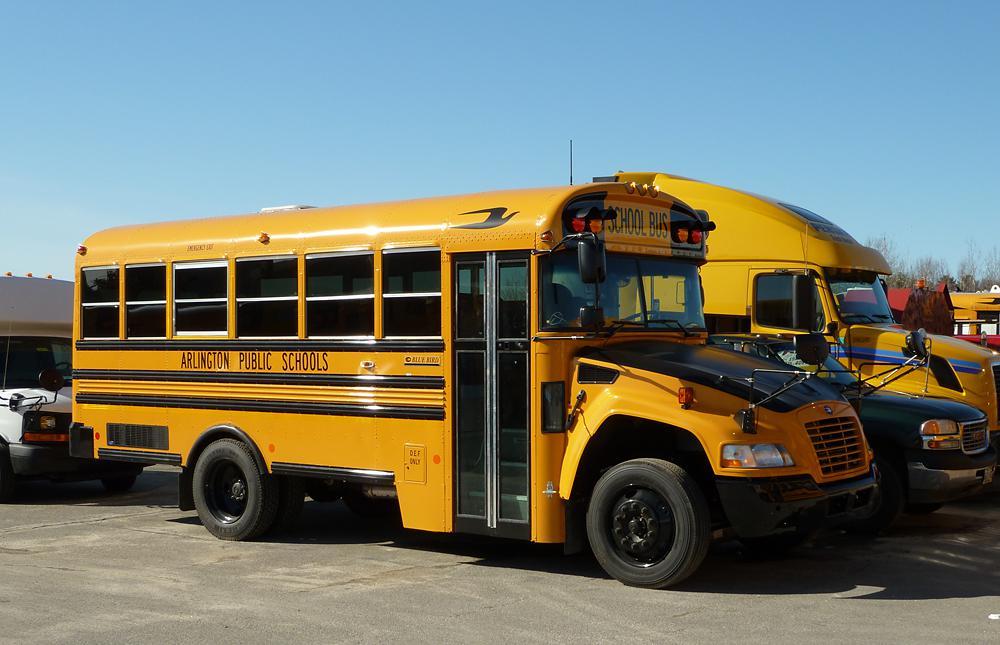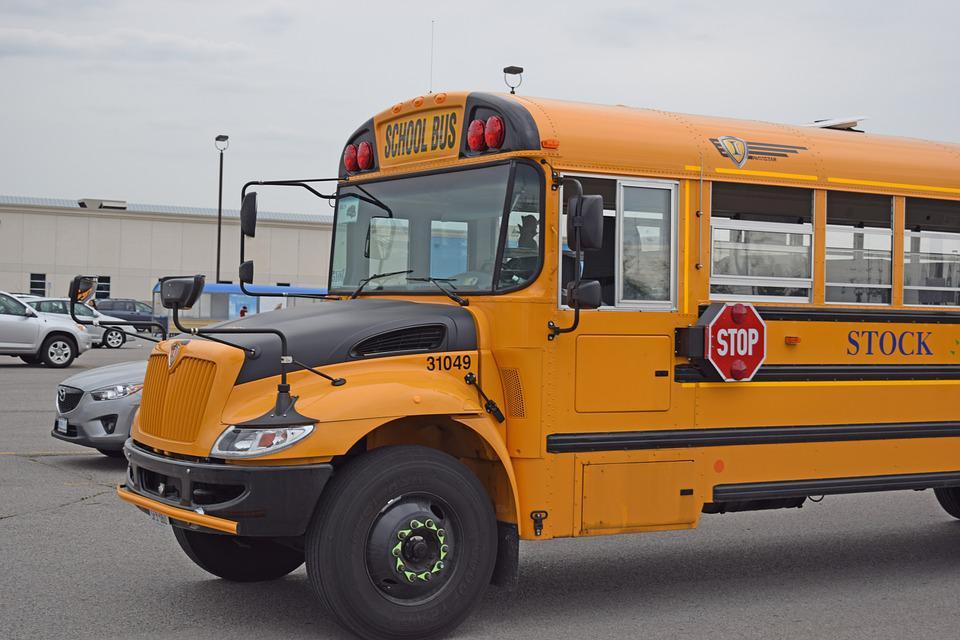The first image is the image on the left, the second image is the image on the right. For the images shown, is this caption "In at least one of the images, a school bus has plowed into a commuter bus." true? Answer yes or no. No. The first image is the image on the left, the second image is the image on the right. For the images displayed, is the sentence "Firefighters dressed in their gear and people wearing yellow safety jackets are working at the scene of a bus accident in at least one of the images." factually correct? Answer yes or no. No. 